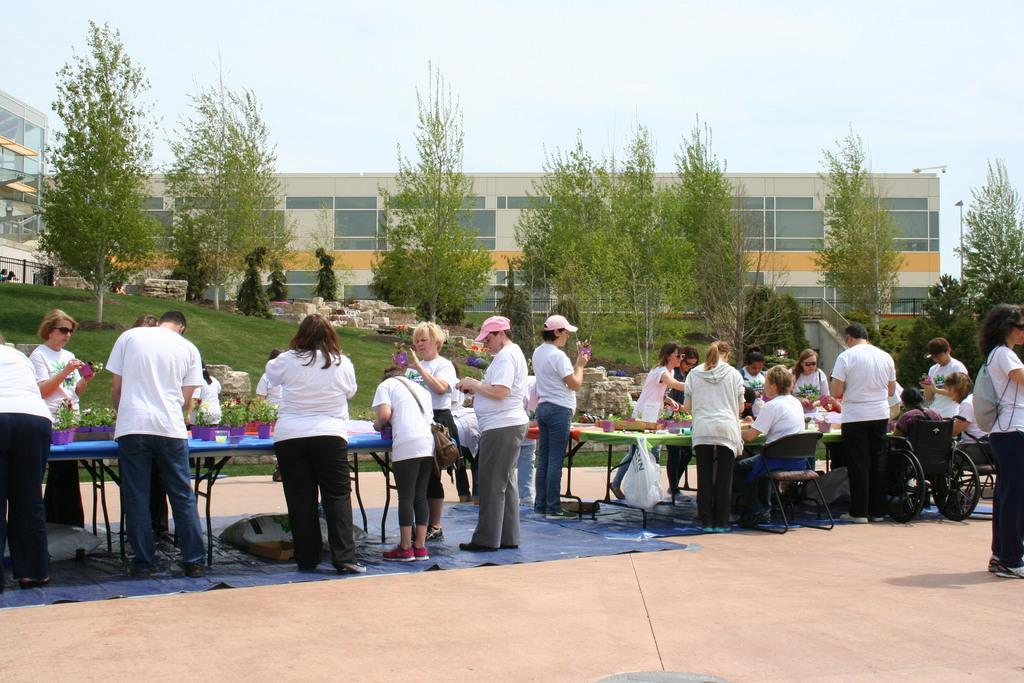What can be seen in the foreground of the image? There are persons standing near the tables in the foreground. What is on top of the tables? There are plants on the tables. What is visible in the background of the image? There are trees, buildings, and the sky in the background. What type of impulse can be seen affecting the geese in the image? There are no geese present in the image, and therefore no impulse can be observed. What is the group of people having for breakfast in the image? There is no mention of breakfast or a group of people eating in the image. 